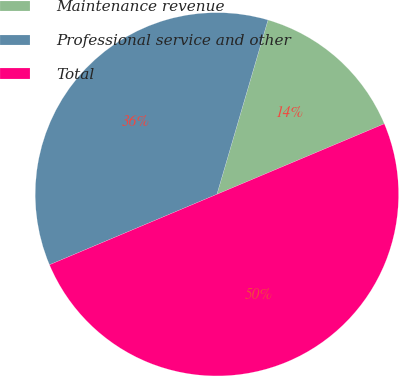<chart> <loc_0><loc_0><loc_500><loc_500><pie_chart><fcel>Maintenance revenue<fcel>Professional service and other<fcel>Total<nl><fcel>14.12%<fcel>35.88%<fcel>50.0%<nl></chart> 